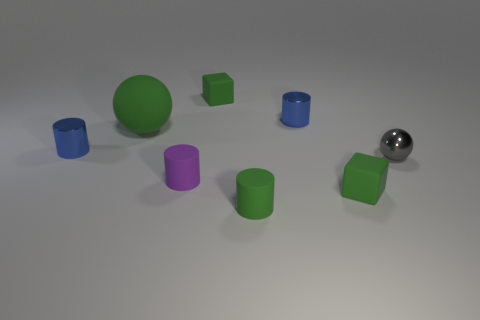Subtract all small green cylinders. How many cylinders are left? 3 Subtract all green spheres. How many spheres are left? 1 Subtract all balls. How many objects are left? 6 Add 2 purple things. How many objects exist? 10 Subtract 2 balls. How many balls are left? 0 Subtract all brown balls. Subtract all purple blocks. How many balls are left? 2 Subtract all gray cubes. How many brown balls are left? 0 Subtract all big purple cubes. Subtract all blue things. How many objects are left? 6 Add 1 small gray metal objects. How many small gray metal objects are left? 2 Add 5 brown rubber objects. How many brown rubber objects exist? 5 